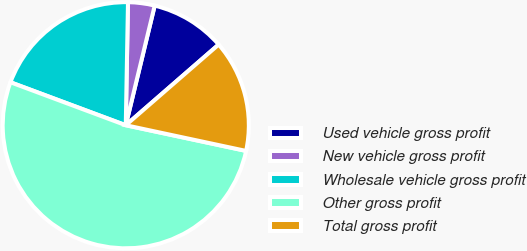<chart> <loc_0><loc_0><loc_500><loc_500><pie_chart><fcel>Used vehicle gross profit<fcel>New vehicle gross profit<fcel>Wholesale vehicle gross profit<fcel>Other gross profit<fcel>Total gross profit<nl><fcel>9.84%<fcel>3.49%<fcel>19.61%<fcel>52.33%<fcel>14.73%<nl></chart> 